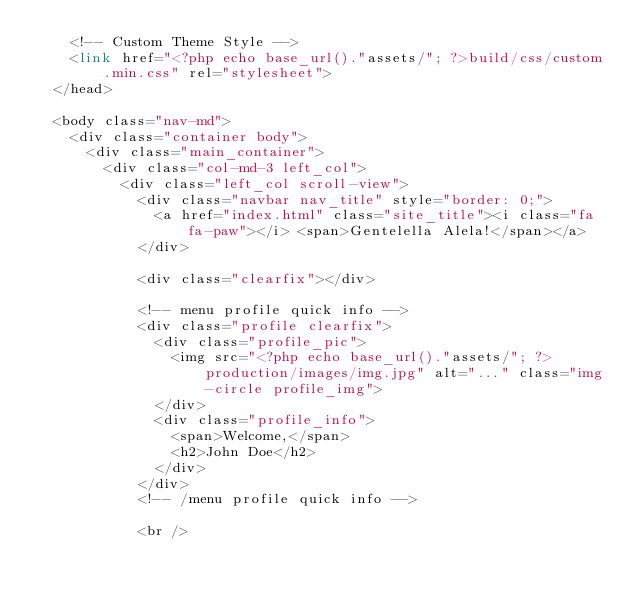Convert code to text. <code><loc_0><loc_0><loc_500><loc_500><_PHP_>    <!-- Custom Theme Style -->
    <link href="<?php echo base_url()."assets/"; ?>build/css/custom.min.css" rel="stylesheet">
  </head>

  <body class="nav-md">
    <div class="container body">
      <div class="main_container">
        <div class="col-md-3 left_col">
          <div class="left_col scroll-view">
            <div class="navbar nav_title" style="border: 0;">
              <a href="index.html" class="site_title"><i class="fa fa-paw"></i> <span>Gentelella Alela!</span></a>
            </div>

            <div class="clearfix"></div>

            <!-- menu profile quick info -->
            <div class="profile clearfix">
              <div class="profile_pic">
                <img src="<?php echo base_url()."assets/"; ?>production/images/img.jpg" alt="..." class="img-circle profile_img">
              </div>
              <div class="profile_info">
                <span>Welcome,</span>
                <h2>John Doe</h2>
              </div>
            </div>
            <!-- /menu profile quick info -->

            <br />
</code> 